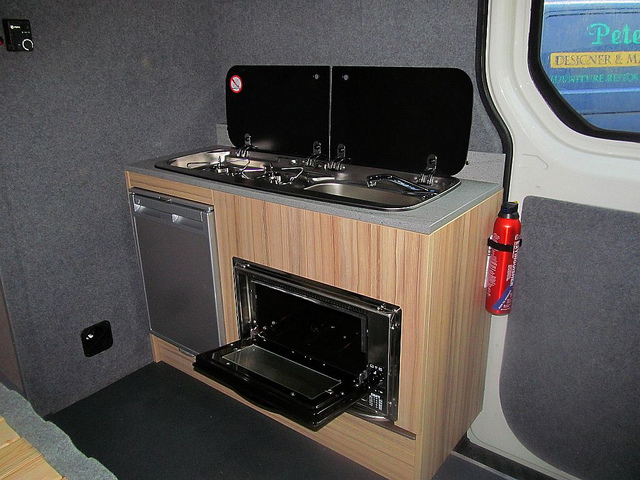Identify the text contained in this image. DESIGNER Pete M. DESIGNER 